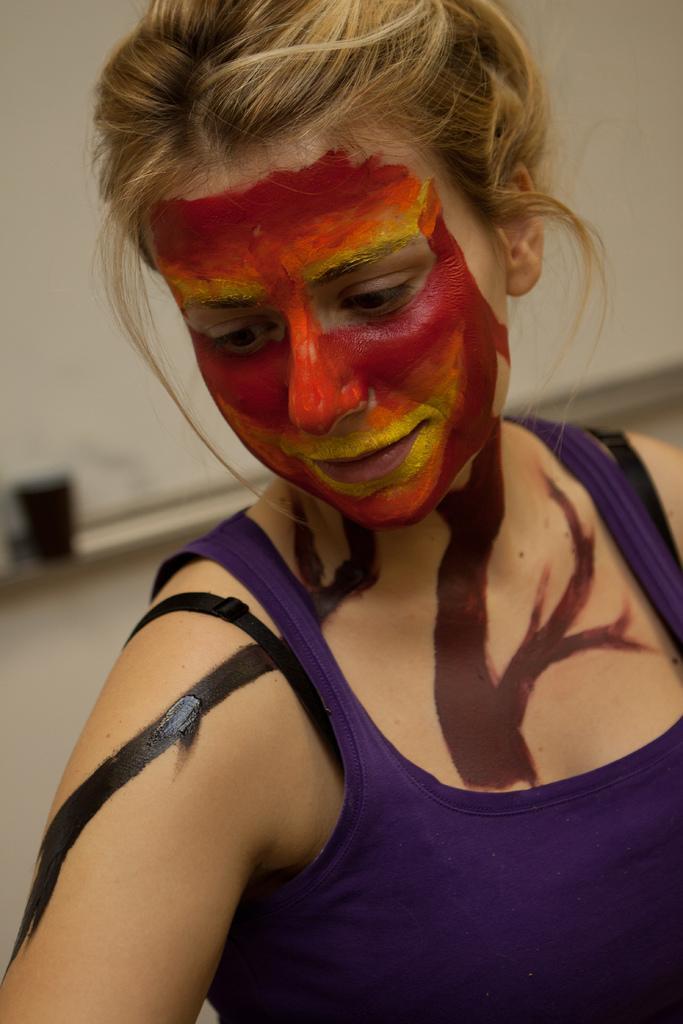How would you summarize this image in a sentence or two? In this image, we can see a person wearing clothes. In the background, image is blurred. 